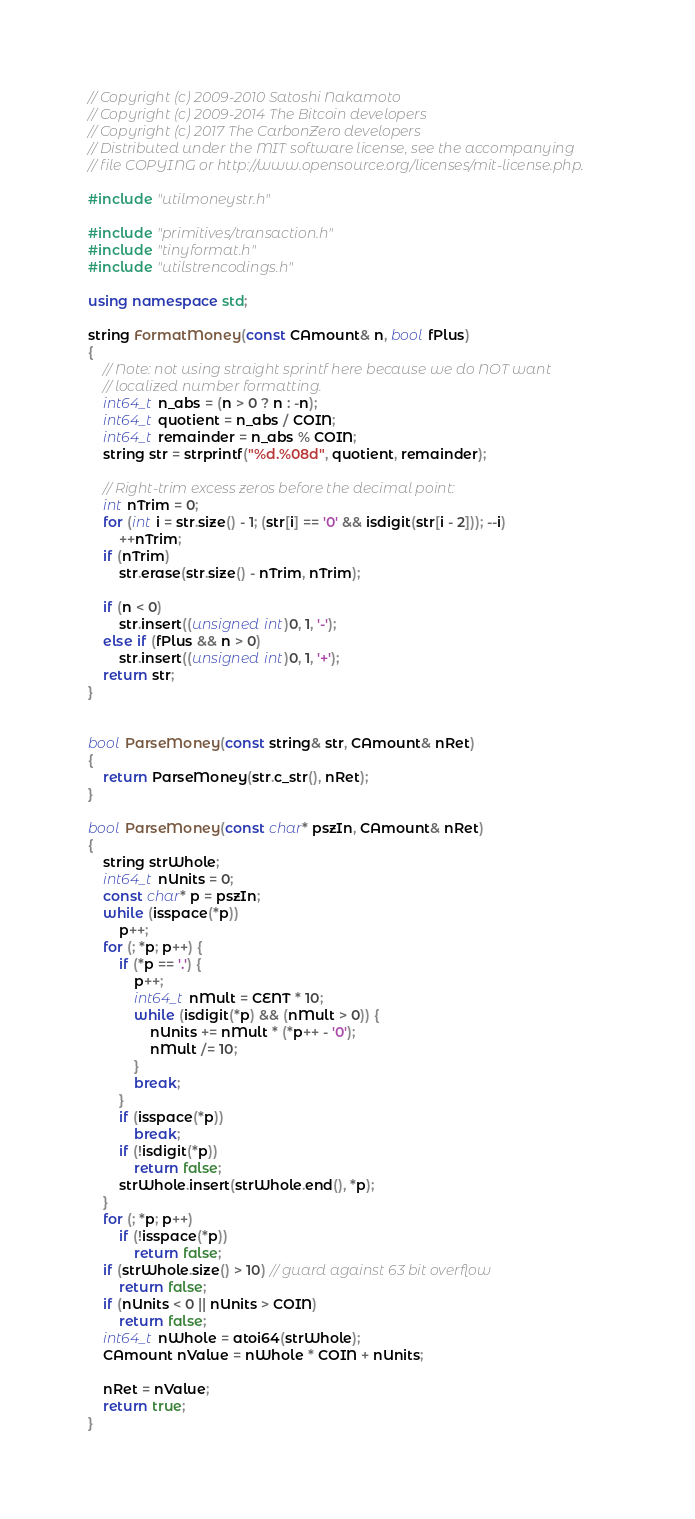Convert code to text. <code><loc_0><loc_0><loc_500><loc_500><_C++_>// Copyright (c) 2009-2010 Satoshi Nakamoto
// Copyright (c) 2009-2014 The Bitcoin developers
// Copyright (c) 2017 The CarbonZero developers
// Distributed under the MIT software license, see the accompanying
// file COPYING or http://www.opensource.org/licenses/mit-license.php.

#include "utilmoneystr.h"

#include "primitives/transaction.h"
#include "tinyformat.h"
#include "utilstrencodings.h"

using namespace std;

string FormatMoney(const CAmount& n, bool fPlus)
{
    // Note: not using straight sprintf here because we do NOT want
    // localized number formatting.
    int64_t n_abs = (n > 0 ? n : -n);
    int64_t quotient = n_abs / COIN;
    int64_t remainder = n_abs % COIN;
    string str = strprintf("%d.%08d", quotient, remainder);

    // Right-trim excess zeros before the decimal point:
    int nTrim = 0;
    for (int i = str.size() - 1; (str[i] == '0' && isdigit(str[i - 2])); --i)
        ++nTrim;
    if (nTrim)
        str.erase(str.size() - nTrim, nTrim);

    if (n < 0)
        str.insert((unsigned int)0, 1, '-');
    else if (fPlus && n > 0)
        str.insert((unsigned int)0, 1, '+');
    return str;
}


bool ParseMoney(const string& str, CAmount& nRet)
{
    return ParseMoney(str.c_str(), nRet);
}

bool ParseMoney(const char* pszIn, CAmount& nRet)
{
    string strWhole;
    int64_t nUnits = 0;
    const char* p = pszIn;
    while (isspace(*p))
        p++;
    for (; *p; p++) {
        if (*p == '.') {
            p++;
            int64_t nMult = CENT * 10;
            while (isdigit(*p) && (nMult > 0)) {
                nUnits += nMult * (*p++ - '0');
                nMult /= 10;
            }
            break;
        }
        if (isspace(*p))
            break;
        if (!isdigit(*p))
            return false;
        strWhole.insert(strWhole.end(), *p);
    }
    for (; *p; p++)
        if (!isspace(*p))
            return false;
    if (strWhole.size() > 10) // guard against 63 bit overflow
        return false;
    if (nUnits < 0 || nUnits > COIN)
        return false;
    int64_t nWhole = atoi64(strWhole);
    CAmount nValue = nWhole * COIN + nUnits;

    nRet = nValue;
    return true;
}
</code> 